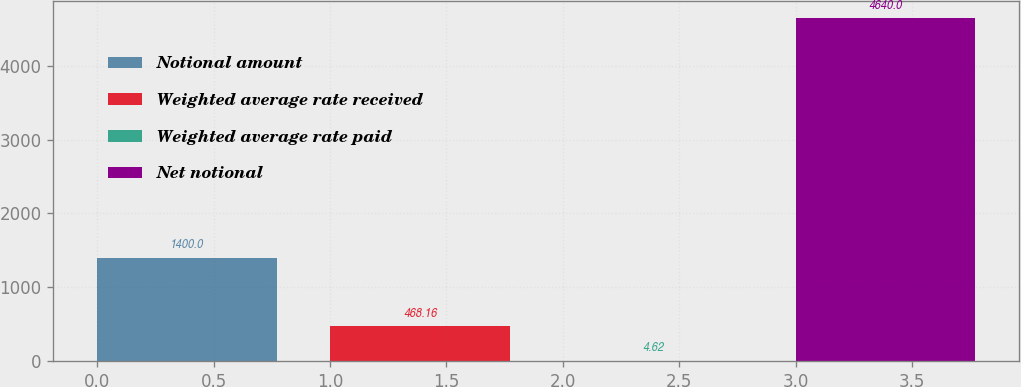<chart> <loc_0><loc_0><loc_500><loc_500><bar_chart><fcel>Notional amount<fcel>Weighted average rate received<fcel>Weighted average rate paid<fcel>Net notional<nl><fcel>1400<fcel>468.16<fcel>4.62<fcel>4640<nl></chart> 